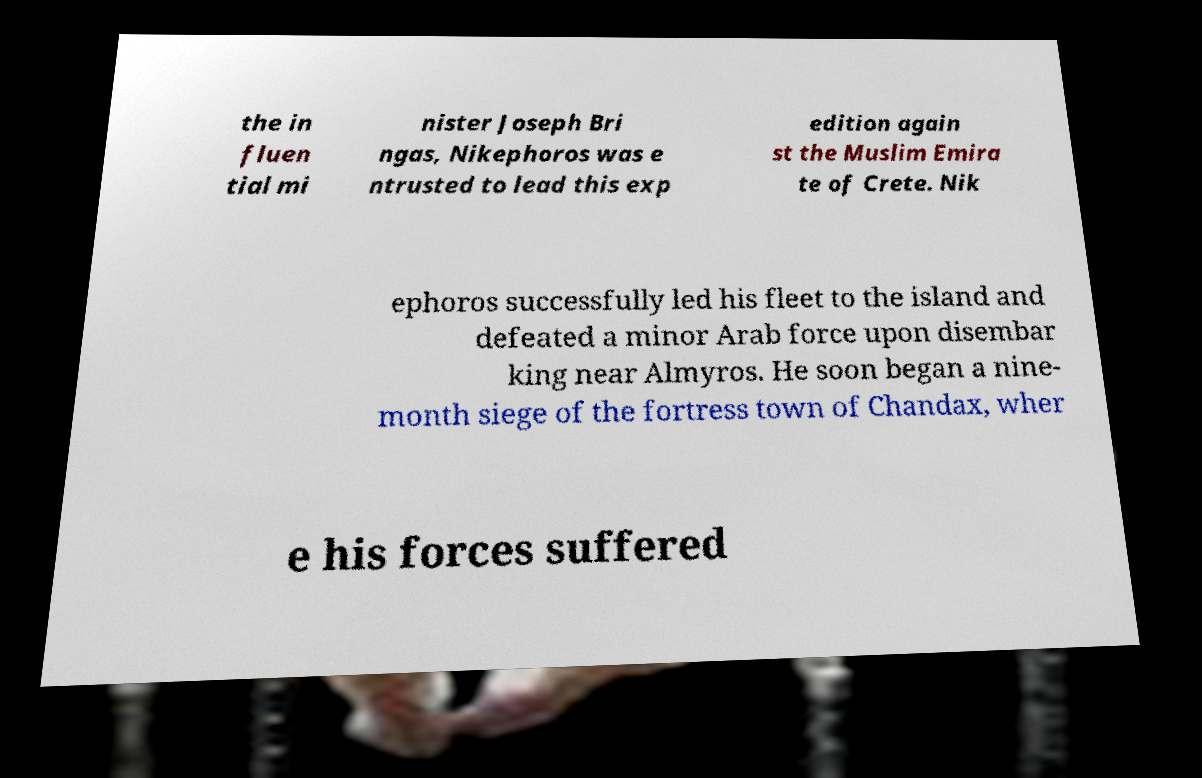Please identify and transcribe the text found in this image. the in fluen tial mi nister Joseph Bri ngas, Nikephoros was e ntrusted to lead this exp edition again st the Muslim Emira te of Crete. Nik ephoros successfully led his fleet to the island and defeated a minor Arab force upon disembar king near Almyros. He soon began a nine- month siege of the fortress town of Chandax, wher e his forces suffered 